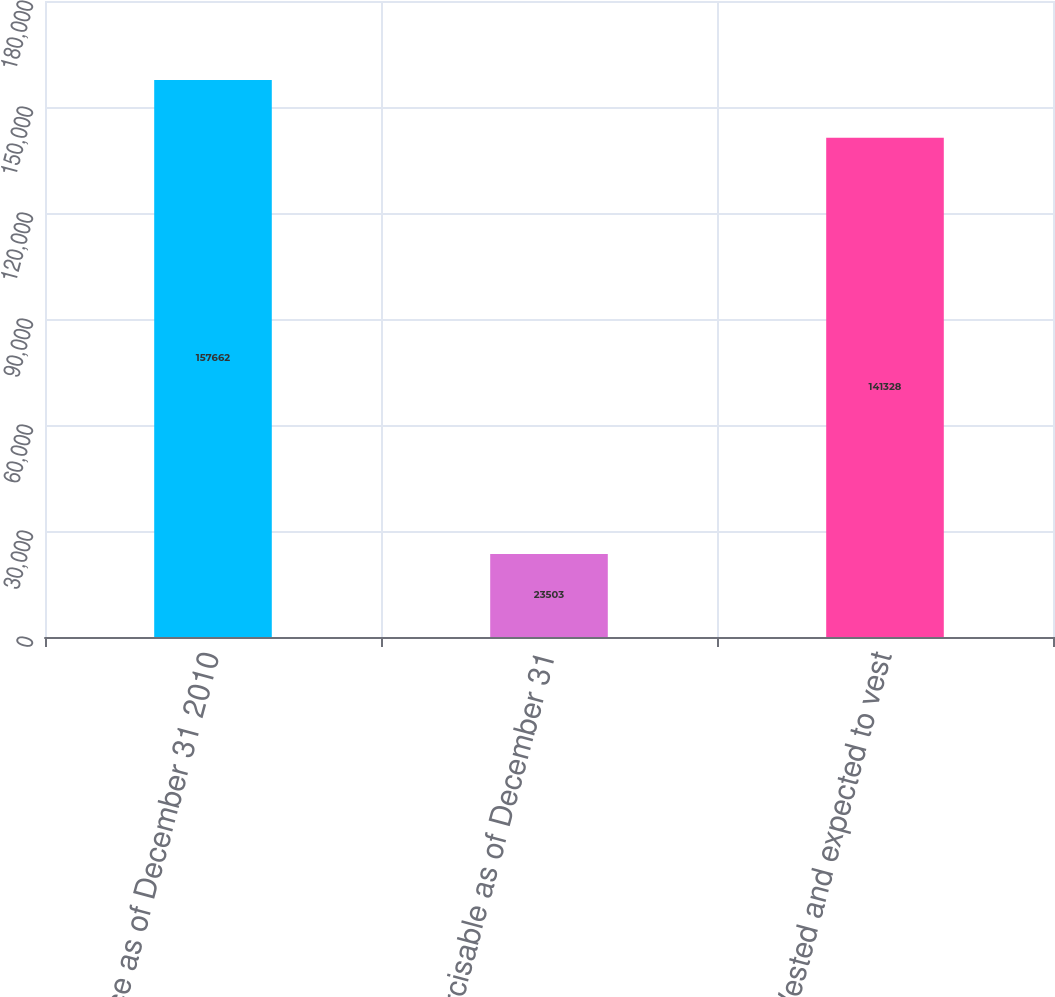Convert chart. <chart><loc_0><loc_0><loc_500><loc_500><bar_chart><fcel>Balance as of December 31 2010<fcel>Exercisable as of December 31<fcel>Vested and expected to vest<nl><fcel>157662<fcel>23503<fcel>141328<nl></chart> 